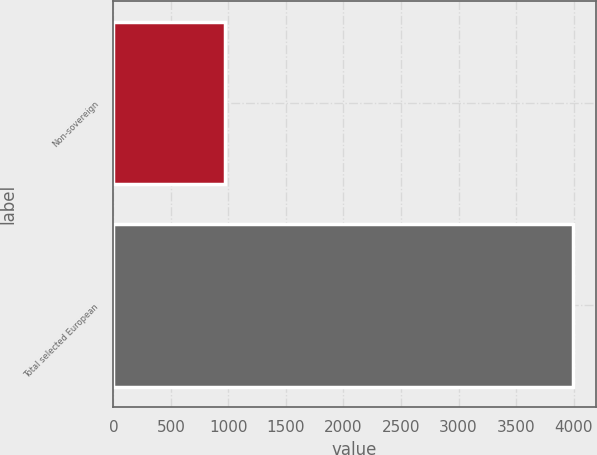Convert chart to OTSL. <chart><loc_0><loc_0><loc_500><loc_500><bar_chart><fcel>Non-sovereign<fcel>Total selected European<nl><fcel>967<fcel>3993<nl></chart> 